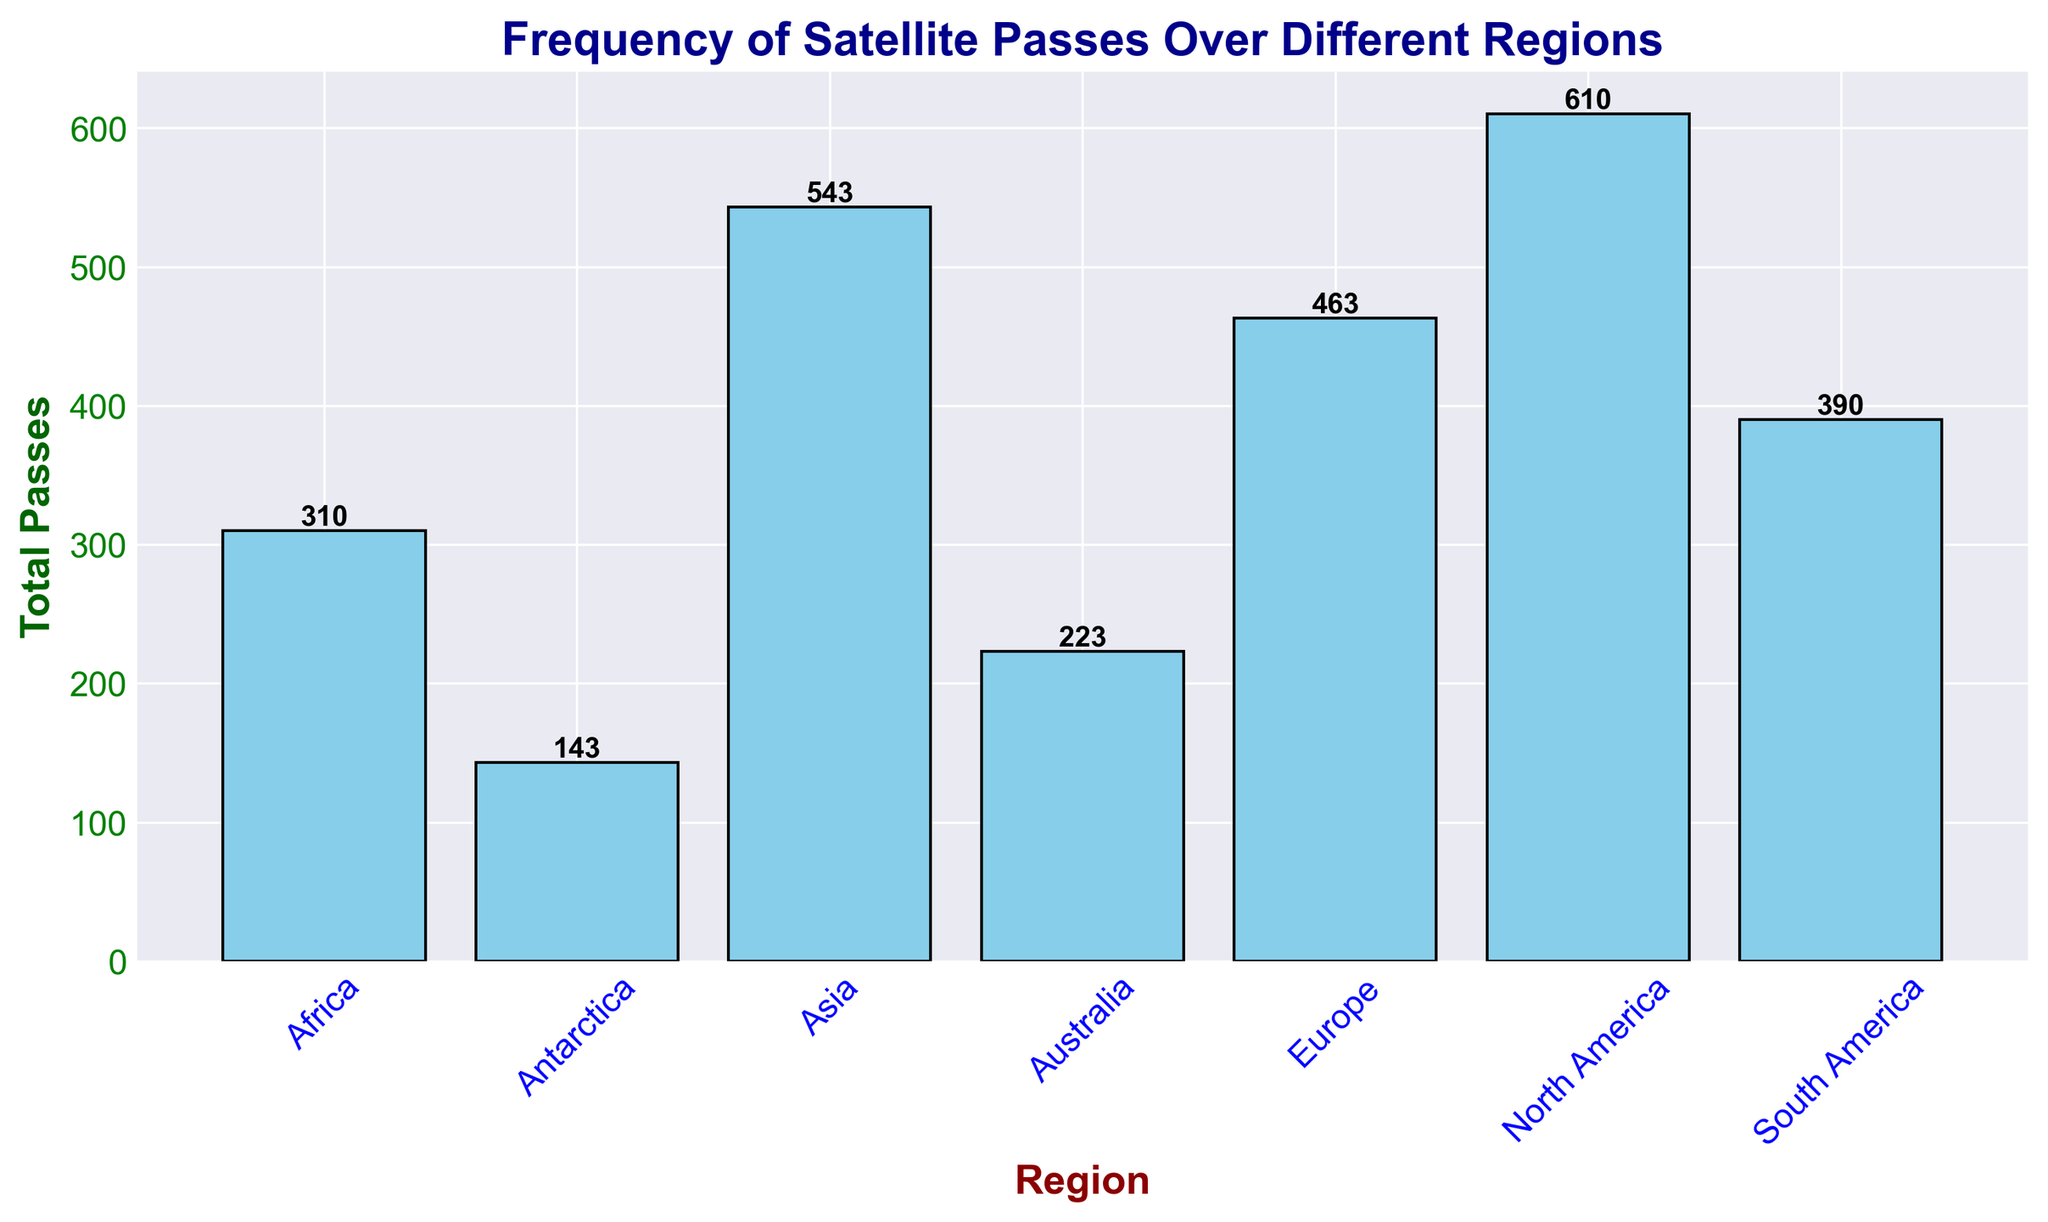Which region has the highest total number of satellite passes? Identify and compare the heights of the bars to determine which one is the tallest. North America has the highest bar, indicating the highest total number of satellite passes.
Answer: North America Which regions have fewer than 100 total satellite passes? Look at the height of each bar and the values displayed on them. Identify bars with values less than 100. Africa, Australia, and Antarctica have fewer than 100 total satellite passes.
Answer: Africa, Australia, Antarctica What is the total number of satellite passes for North America and Europe combined? Find the values for North America and Europe by looking at the heights/labels of their respective bars. Sum these values (610 for North America and 463 for Europe).
Answer: 1073 How many more satellite passes does Asia have compared to Antarctica? Identify the values for Asia and Antarctica by looking at the bar heights/labels. Take the difference (543 for Asia minus 143 for Antarctica).
Answer: 400 Which region shows the smallest total number of satellite passes? Identify and compare the heights of the bars to determine which one is the shortest. Antarctica has the smallest bar, indicating the smallest total number of satellite passes.
Answer: Antarctica What are the total passes for regions in the Southern Hemisphere (South America, Africa, Australia, Antarctica)? Identify the values for the regions in the southern hemisphere and sum them up (390 for South America, 310 for Africa, 223 for Australia, and 143 for Antarctica).
Answer: 1066 Is the total number of passes for Europe and Asia combined higher than that for North America? Find the values for Europe and Asia, and then sum them (463 for Europe plus 543 for Asia equals 1006). Compare this total to North America's total (610).
Answer: No Which region has the second highest total number of satellite passes? After identifying that North America has the highest, check the remaining bars and compare their heights/values. Asia has the second highest bar.
Answer: Asia How many satellites passes are there in total for the entire dataset? Sum the total number of passes for all regions: North America (610), South America (390), Europe (463), Africa (310), Asia (543), Australia (223), and Antarctica (143).
Answer: 2682 What is the average number of satellite passes in each region? Calculate the total number of satellite passes (2682) and divide by the number of regions (7).
Answer: 383.14 